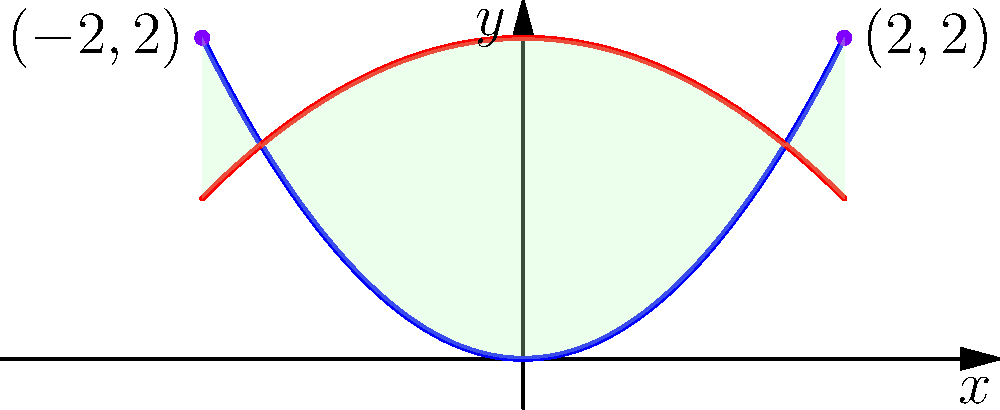Two musical scales are represented by the parabolas $y = 0.5x^2$ and $y = 2 - 0.25x^2$. These parabolas intersect at two points, creating a shape between them. Calculate the area of this shape, which represents the harmonic overlap between the two scales. Express your answer in square units. Let's approach this step-by-step:

1) First, we need to find the points of intersection. We can do this by equating the two functions:

   $0.5x^2 = 2 - 0.25x^2$

2) Rearranging the equation:

   $0.75x^2 = 2$
   $x^2 = \frac{8}{3}$
   $x = \pm \sqrt{\frac{8}{3}} = \pm 2\sqrt{\frac{2}{3}}$

3) The points of intersection are $(-2,2)$ and $(2,2)$.

4) To find the area between the curves, we need to integrate the difference of the functions between these points:

   $Area = \int_{-2}^{2} [(2 - 0.25x^2) - (0.5x^2)] dx$

5) Simplifying the integrand:

   $Area = \int_{-2}^{2} [2 - 0.75x^2] dx$

6) Integrating:

   $Area = [2x - 0.25x^3]_{-2}^{2}$

7) Evaluating the integral:

   $Area = (4 - 2) - (-4 - 2) = 8$

Therefore, the area between the two parabolas is 8 square units.
Answer: 8 square units 